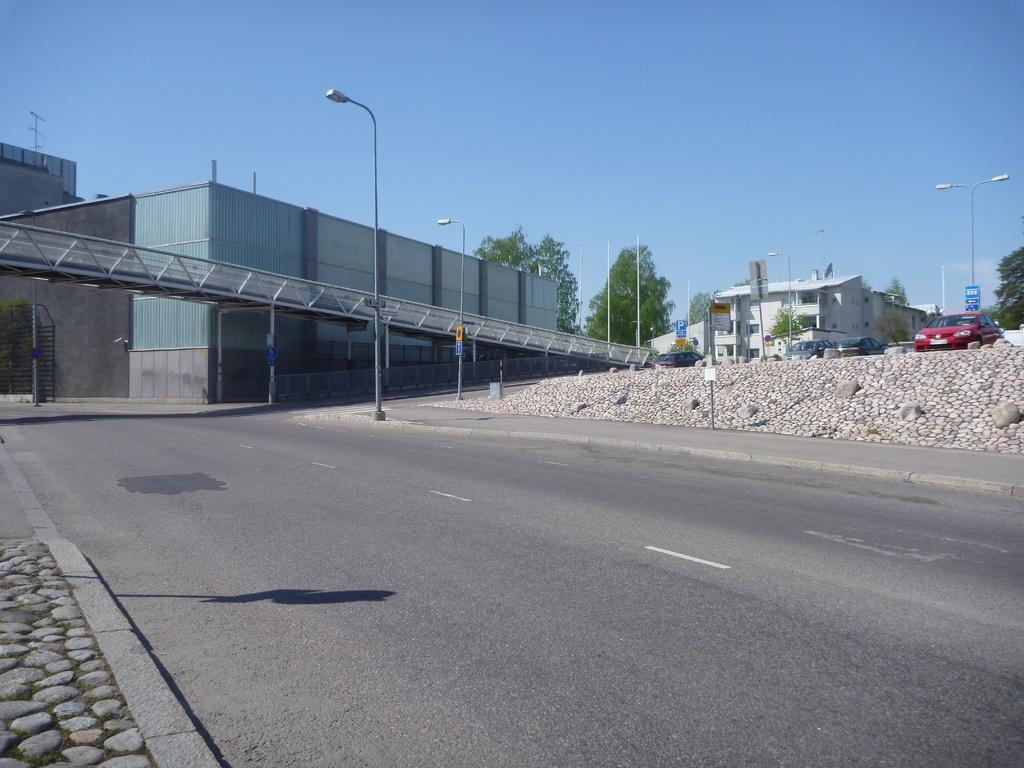Could you give a brief overview of what you see in this image? In this image, there are a few buildings and vehicles. We can see some poles, trees, a bridge. We can see the ground and some boards with text. We can also see a black colored object. We can also see the sky and some rocks. 